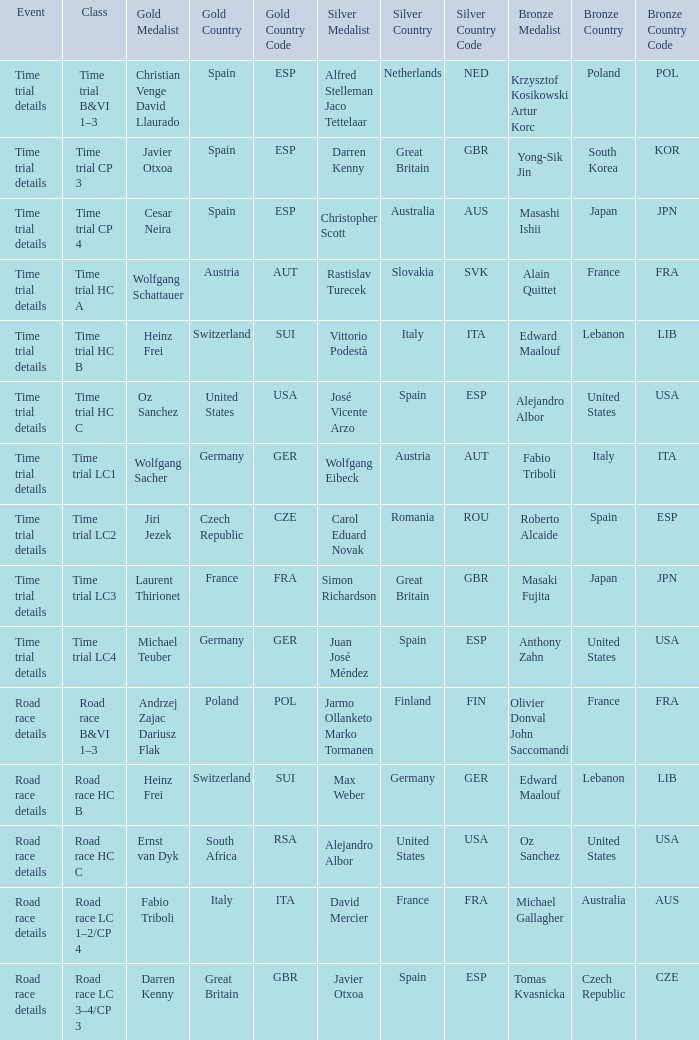Who secured the gold medal in the time trial competition in which simon richardson from great britain (gbr) earned a silver medal? Laurent Thirionet France (FRA). 